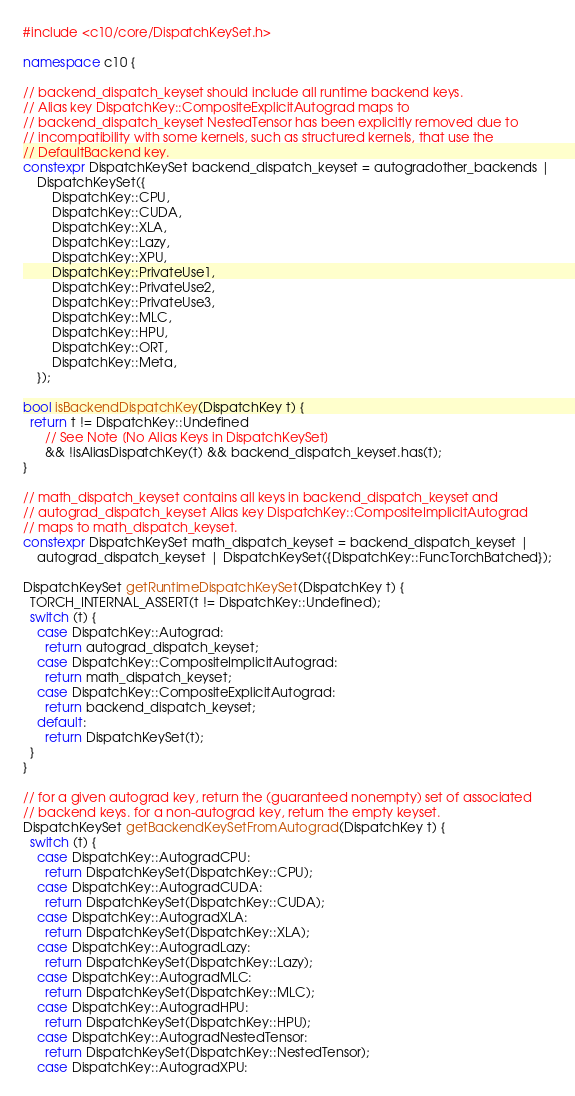<code> <loc_0><loc_0><loc_500><loc_500><_C++_>#include <c10/core/DispatchKeySet.h>

namespace c10 {

// backend_dispatch_keyset should include all runtime backend keys.
// Alias key DispatchKey::CompositeExplicitAutograd maps to
// backend_dispatch_keyset NestedTensor has been explicitly removed due to
// incompatibility with some kernels, such as structured kernels, that use the
// DefaultBackend key.
constexpr DispatchKeySet backend_dispatch_keyset = autogradother_backends |
    DispatchKeySet({
        DispatchKey::CPU,
        DispatchKey::CUDA,
        DispatchKey::XLA,
        DispatchKey::Lazy,
        DispatchKey::XPU,
        DispatchKey::PrivateUse1,
        DispatchKey::PrivateUse2,
        DispatchKey::PrivateUse3,
        DispatchKey::MLC,
        DispatchKey::HPU,
        DispatchKey::ORT,
        DispatchKey::Meta,
    });

bool isBackendDispatchKey(DispatchKey t) {
  return t != DispatchKey::Undefined
      // See Note [No Alias Keys in DispatchKeySet]
      && !isAliasDispatchKey(t) && backend_dispatch_keyset.has(t);
}

// math_dispatch_keyset contains all keys in backend_dispatch_keyset and
// autograd_dispatch_keyset Alias key DispatchKey::CompositeImplicitAutograd
// maps to math_dispatch_keyset.
constexpr DispatchKeySet math_dispatch_keyset = backend_dispatch_keyset |
    autograd_dispatch_keyset | DispatchKeySet({DispatchKey::FuncTorchBatched});

DispatchKeySet getRuntimeDispatchKeySet(DispatchKey t) {
  TORCH_INTERNAL_ASSERT(t != DispatchKey::Undefined);
  switch (t) {
    case DispatchKey::Autograd:
      return autograd_dispatch_keyset;
    case DispatchKey::CompositeImplicitAutograd:
      return math_dispatch_keyset;
    case DispatchKey::CompositeExplicitAutograd:
      return backend_dispatch_keyset;
    default:
      return DispatchKeySet(t);
  }
}

// for a given autograd key, return the (guaranteed nonempty) set of associated
// backend keys. for a non-autograd key, return the empty keyset.
DispatchKeySet getBackendKeySetFromAutograd(DispatchKey t) {
  switch (t) {
    case DispatchKey::AutogradCPU:
      return DispatchKeySet(DispatchKey::CPU);
    case DispatchKey::AutogradCUDA:
      return DispatchKeySet(DispatchKey::CUDA);
    case DispatchKey::AutogradXLA:
      return DispatchKeySet(DispatchKey::XLA);
    case DispatchKey::AutogradLazy:
      return DispatchKeySet(DispatchKey::Lazy);
    case DispatchKey::AutogradMLC:
      return DispatchKeySet(DispatchKey::MLC);
    case DispatchKey::AutogradHPU:
      return DispatchKeySet(DispatchKey::HPU);
    case DispatchKey::AutogradNestedTensor:
      return DispatchKeySet(DispatchKey::NestedTensor);
    case DispatchKey::AutogradXPU:</code> 